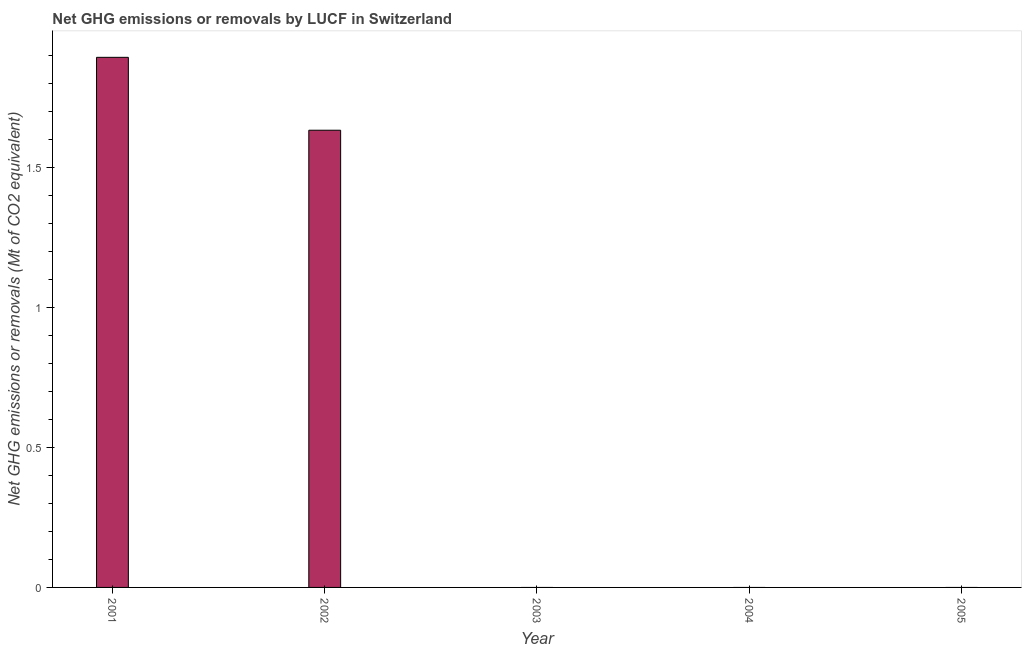Does the graph contain grids?
Ensure brevity in your answer.  No. What is the title of the graph?
Offer a very short reply. Net GHG emissions or removals by LUCF in Switzerland. What is the label or title of the X-axis?
Provide a short and direct response. Year. What is the label or title of the Y-axis?
Ensure brevity in your answer.  Net GHG emissions or removals (Mt of CO2 equivalent). Across all years, what is the maximum ghg net emissions or removals?
Your answer should be compact. 1.89. In which year was the ghg net emissions or removals maximum?
Keep it short and to the point. 2001. What is the sum of the ghg net emissions or removals?
Provide a short and direct response. 3.53. What is the difference between the ghg net emissions or removals in 2001 and 2002?
Offer a very short reply. 0.26. What is the average ghg net emissions or removals per year?
Provide a short and direct response. 0.71. What is the median ghg net emissions or removals?
Offer a terse response. 0. In how many years, is the ghg net emissions or removals greater than 1.2 Mt?
Provide a short and direct response. 2. What is the difference between the highest and the lowest ghg net emissions or removals?
Your answer should be compact. 1.89. In how many years, is the ghg net emissions or removals greater than the average ghg net emissions or removals taken over all years?
Offer a very short reply. 2. How many bars are there?
Give a very brief answer. 2. What is the difference between two consecutive major ticks on the Y-axis?
Your answer should be very brief. 0.5. Are the values on the major ticks of Y-axis written in scientific E-notation?
Offer a very short reply. No. What is the Net GHG emissions or removals (Mt of CO2 equivalent) of 2001?
Keep it short and to the point. 1.89. What is the Net GHG emissions or removals (Mt of CO2 equivalent) in 2002?
Give a very brief answer. 1.63. What is the Net GHG emissions or removals (Mt of CO2 equivalent) of 2005?
Offer a terse response. 0. What is the difference between the Net GHG emissions or removals (Mt of CO2 equivalent) in 2001 and 2002?
Provide a succinct answer. 0.26. What is the ratio of the Net GHG emissions or removals (Mt of CO2 equivalent) in 2001 to that in 2002?
Ensure brevity in your answer.  1.16. 